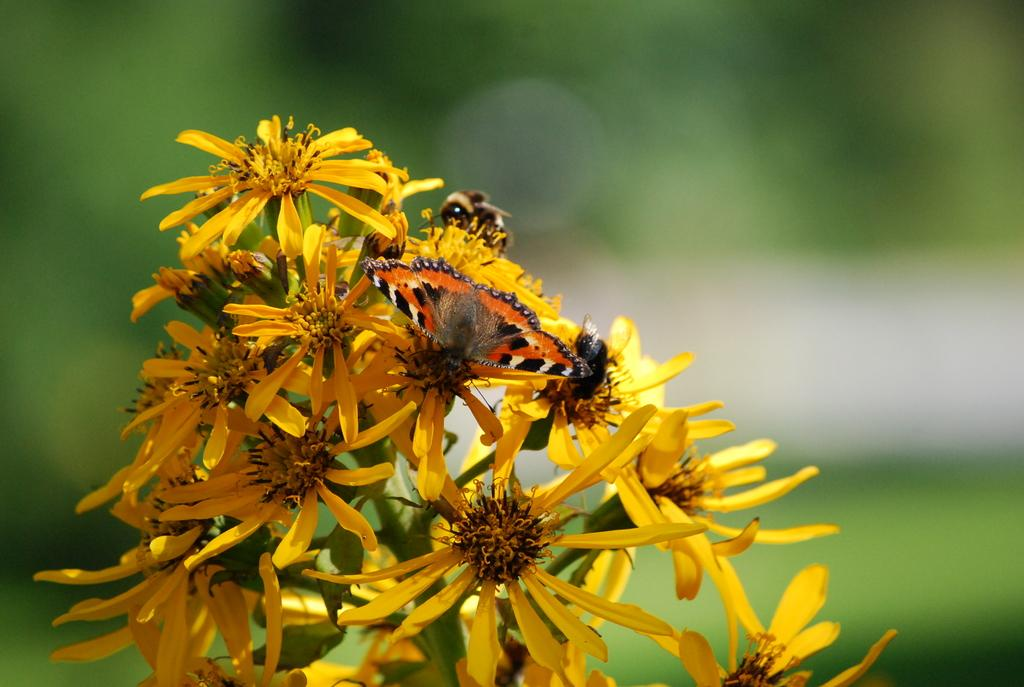What is the main subject in the center of the image? There is a butterfly in the center of the image. What other elements can be seen in the image? There are flowers in the image. How would you describe the background of the image? The background of the image is blurry. What type of grape is being used as a weapon in the battle depicted in the image? There is no battle or grape present in the image; it features a butterfly and flowers. Can you tell me how many seeds are visible on the butterfly in the image? There are no seeds visible on the butterfly in the image; it is a butterfly, not a fruit or plant. 